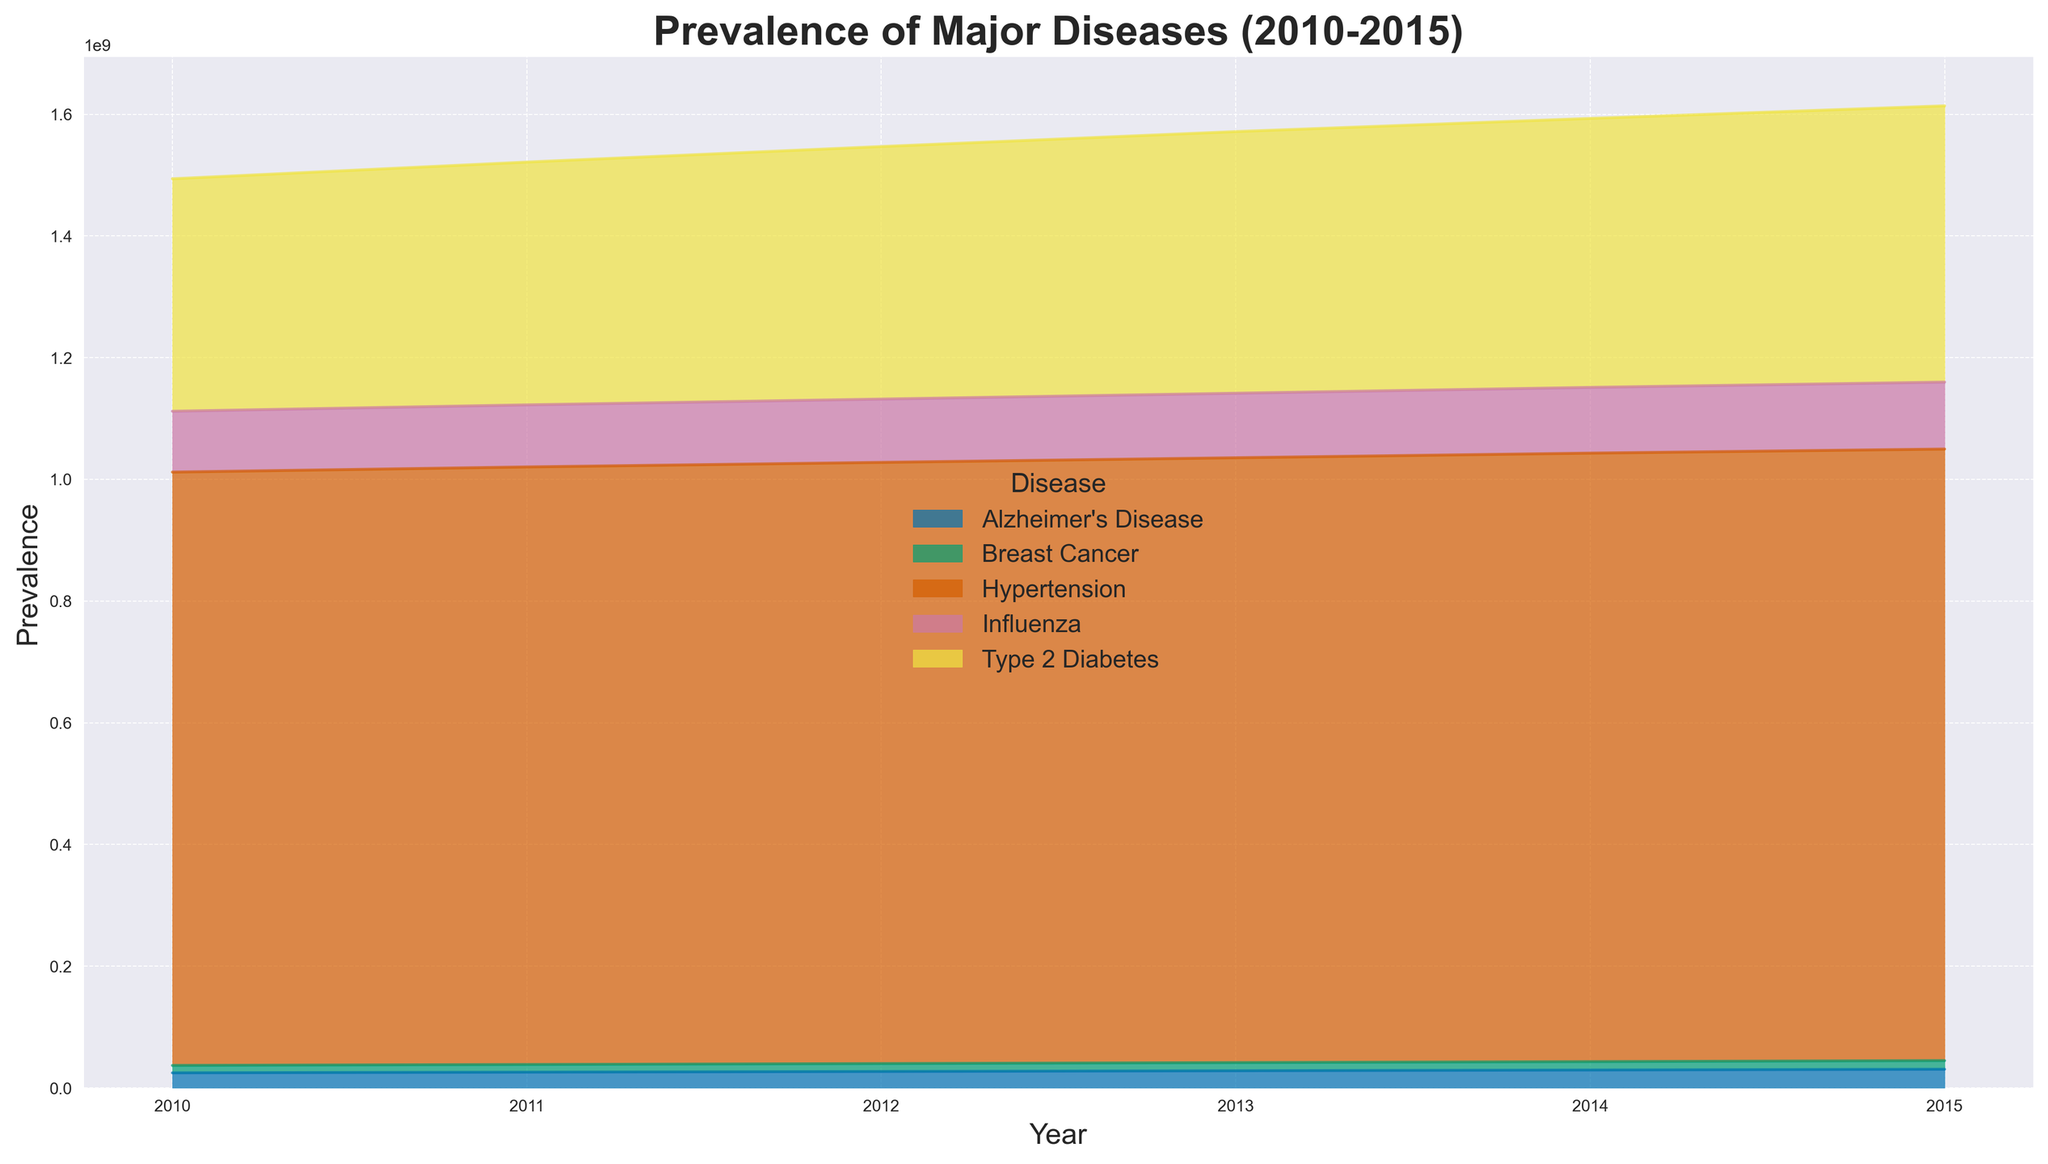Which disease had the highest prevalence in 2015? To determine which disease had the highest prevalence in 2015, you need to look at the end of the chart for each disease. The largest area height visually represents the highest prevalence.
Answer: Hypertension How did the prevalence of Type 2 Diabetes change from 2010 to 2015? Compare the heights of the colored area representing Type 2 Diabetes at the start (2010) and the end (2015) of the chart. Note the increase in height, which corresponds to an increase in prevalence.
Answer: It increased Which disease showed the least change in prevalence from 2010 to 2015? To identify the disease with the least change, observe the differences in the heights of colored areas between 2010 and 2015. The area with the smallest difference represents the least change in prevalence.
Answer: Alzheimer's Disease What was the combined prevalence of Hypertension and Influenza in 2013? Locate the heights of the Hypertension and Influenza areas for the year 2013, add these values together to find the combined prevalence.
Answer: 1,100,000,000 + 106,000,000 = 1,206,000,000 Which disease had a higher prevalence in 2012: Alzheimer's Disease or Breast Cancer? Compare the respective heights of the colored areas for Alzheimer’s Disease and Breast Cancer in the year 2012.
Answer: Alzheimer's Disease How does the prevalence of Breast Cancer visually compare to that of Influenza in 2010? Observe the height differences between the areas representing Breast Cancer and Influenza in the year 2010.
Answer: Influenza is higher Was there a point where the prevalence of Influenza surpassed that of Type 2 Diabetes? Track the heights of the colored areas for Influenza and Type 2 Diabetes year by year to identify any instance where Influenza's height exceeds that of Type 2 Diabetes.
Answer: No What trend can be observed in the prevalence of Type 2 Diabetes from 2010 to 2015? By examining the area height for Type 2 Diabetes over the years from 2010 to 2015, we can see an upward trend, indicating an increase in prevalence over time.
Answer: Increasing trend What year saw the sharpest rise in the prevalence of Alzheimer's Disease? Look at the annual differences in the area heights for Alzheimer’s Disease. The year with the most significant increase in height indicates the sharpest rise in prevalence.
Answer: 2015 How does the prevalence of Hypertension in 2011 compare to its prevalence in 2015? Compare the heights of the Hypertension areas in 2011 and 2015. The difference in height represents the change in prevalence.
Answer: It's higher in 2015 